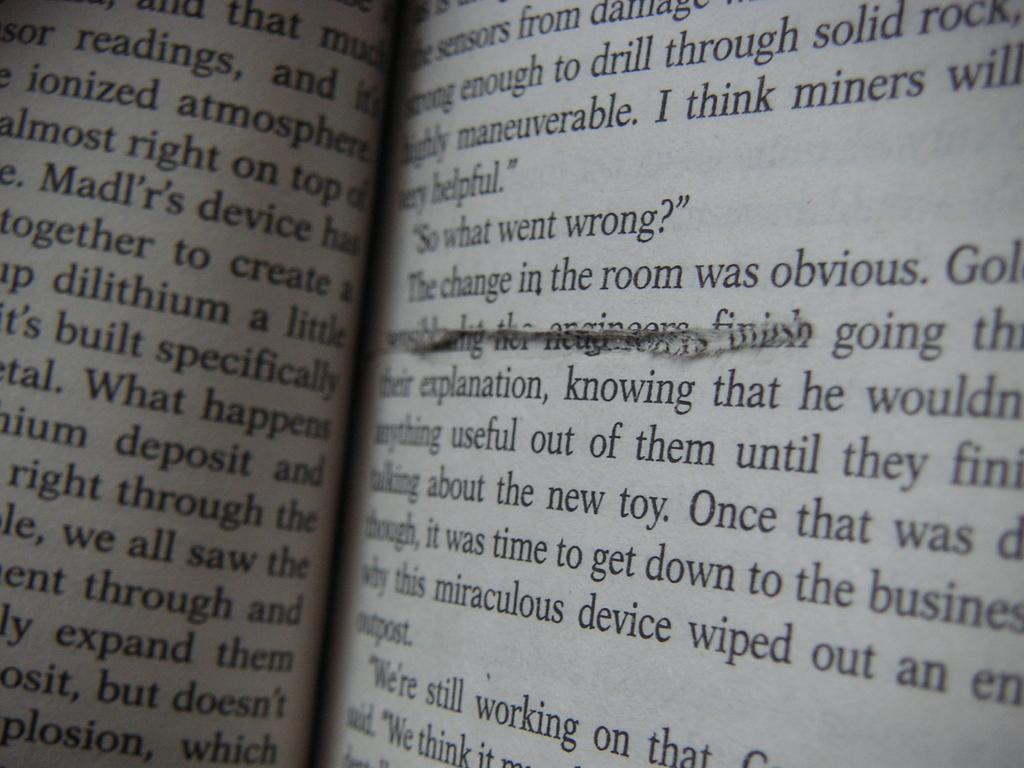<image>
Relay a brief, clear account of the picture shown. A book page is torn or cut below the words "in the room was obvious". 